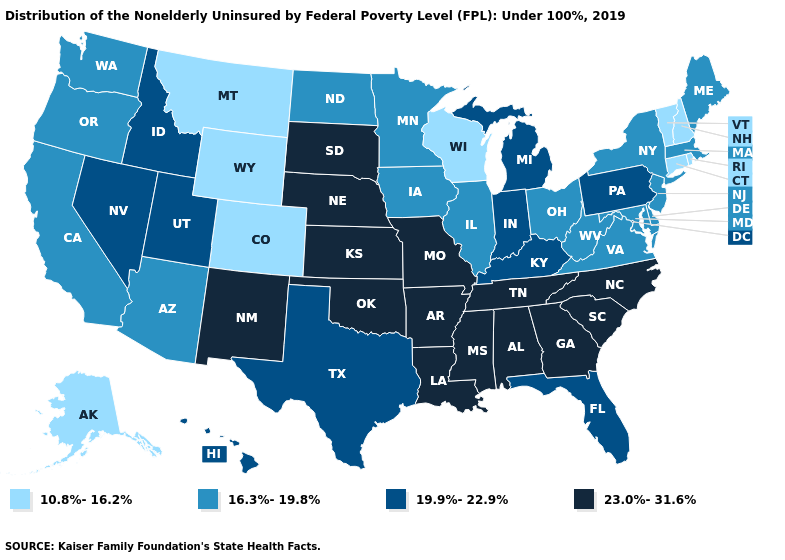How many symbols are there in the legend?
Concise answer only. 4. What is the value of Connecticut?
Be succinct. 10.8%-16.2%. What is the value of South Dakota?
Write a very short answer. 23.0%-31.6%. What is the value of Ohio?
Short answer required. 16.3%-19.8%. Does Texas have the same value as Arizona?
Quick response, please. No. Name the states that have a value in the range 23.0%-31.6%?
Write a very short answer. Alabama, Arkansas, Georgia, Kansas, Louisiana, Mississippi, Missouri, Nebraska, New Mexico, North Carolina, Oklahoma, South Carolina, South Dakota, Tennessee. What is the value of Nebraska?
Give a very brief answer. 23.0%-31.6%. What is the value of Maine?
Answer briefly. 16.3%-19.8%. Name the states that have a value in the range 19.9%-22.9%?
Answer briefly. Florida, Hawaii, Idaho, Indiana, Kentucky, Michigan, Nevada, Pennsylvania, Texas, Utah. Does Rhode Island have the lowest value in the USA?
Answer briefly. Yes. What is the lowest value in the USA?
Give a very brief answer. 10.8%-16.2%. What is the value of New Hampshire?
Be succinct. 10.8%-16.2%. Which states have the highest value in the USA?
Be succinct. Alabama, Arkansas, Georgia, Kansas, Louisiana, Mississippi, Missouri, Nebraska, New Mexico, North Carolina, Oklahoma, South Carolina, South Dakota, Tennessee. Name the states that have a value in the range 16.3%-19.8%?
Quick response, please. Arizona, California, Delaware, Illinois, Iowa, Maine, Maryland, Massachusetts, Minnesota, New Jersey, New York, North Dakota, Ohio, Oregon, Virginia, Washington, West Virginia. Does Texas have the highest value in the South?
Short answer required. No. 